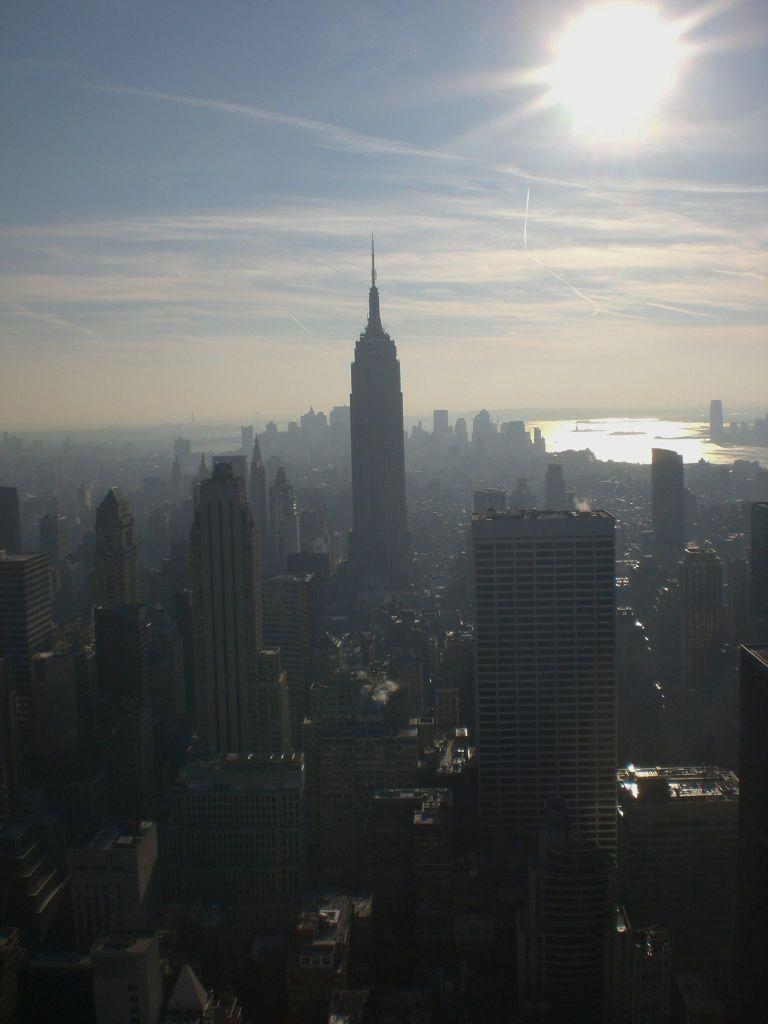What type of location is depicted in the image? The image depicts a city. What are some notable features of the city? There are skyscraper buildings and roads in the city. What natural feature can be seen on the right side of the image? There is a river on the right side of the image. What is visible at the top of the image? The sky is visible at the top of the image, and it contains clouds and the sun. What type of songs can be heard coming from the clam in the image? There is no clam present in the image, and therefore no songs can be heard. What type of flower is growing on the side of the skyscraper building? There are no flowers visible on the side of the skyscraper building in the image. 